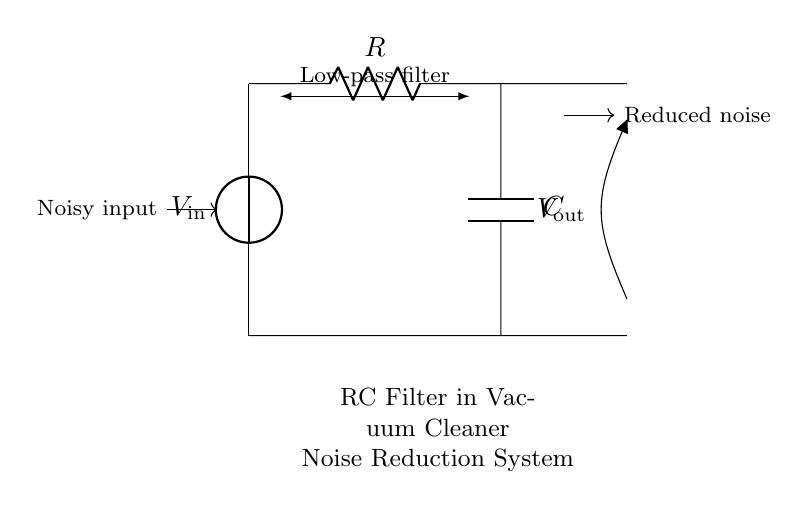What type of filter is represented in this circuit? The circuit diagram shows an RC (Resistor-Capacitor) filter, specifically a low-pass filter, which allows low-frequency signals to pass through while attenuating higher frequencies. This is indicated by the label "Low-pass filter" in the diagram.
Answer: Low-pass filter What are the values of the components in the circuit? The circuit includes a resistor labeled R and a capacitor labeled C. However, specific numerical values for these components are not provided in the diagram itself. The general representation implies that they could be replaced by any appropriate values depending on the application.
Answer: R and C What is the role of the capacitor in this filter? The capacitor in an RC filter acts to store and release electrical energy. In the context of noise reduction, it smooths out fluctuations in voltage, reducing high-frequency noise from the input, as indicated by its placement in the circuit and the expected function of a low-pass filter.
Answer: Smooths voltage What happens to the noise in this circuit? The circuit is designed to reduce noise by allowing low-frequency signals to pass while blocking or diminishing high-frequency noise. This is achieved through the combination of the resistor and capacitor, which create a frequency-dependent response.
Answer: Reduced noise What is V_in in relation to V_out? V_in represents the noisy input voltage, while V_out is the output voltage after it has passed through the RC filter. Since this is a low-pass filter, the V_out will have lower amplitude for high-frequency components compared to V_in, effectively cleaning the signal.
Answer: Noisy input How does the resistor affect the filter's performance? The resistor in the RC filter determines the time constant, which affects how quickly the capacitor charges and discharges. A higher resistance leads to a slower response to changes in input voltage, influencing the filter's cutoff frequency and ultimately its ability to attenuate noise.
Answer: Influences response 